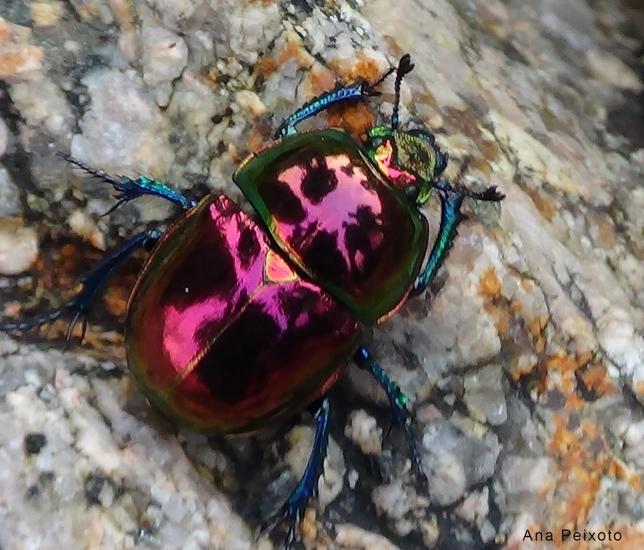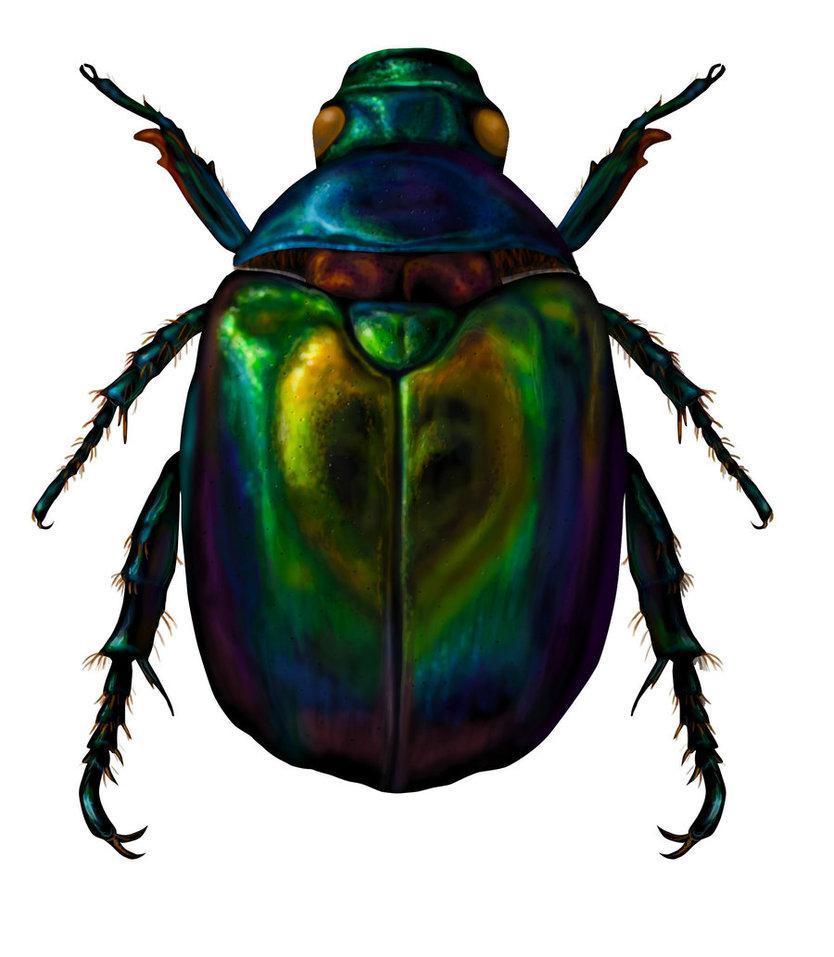The first image is the image on the left, the second image is the image on the right. For the images shown, is this caption "There are two black beetles in total." true? Answer yes or no. No. 